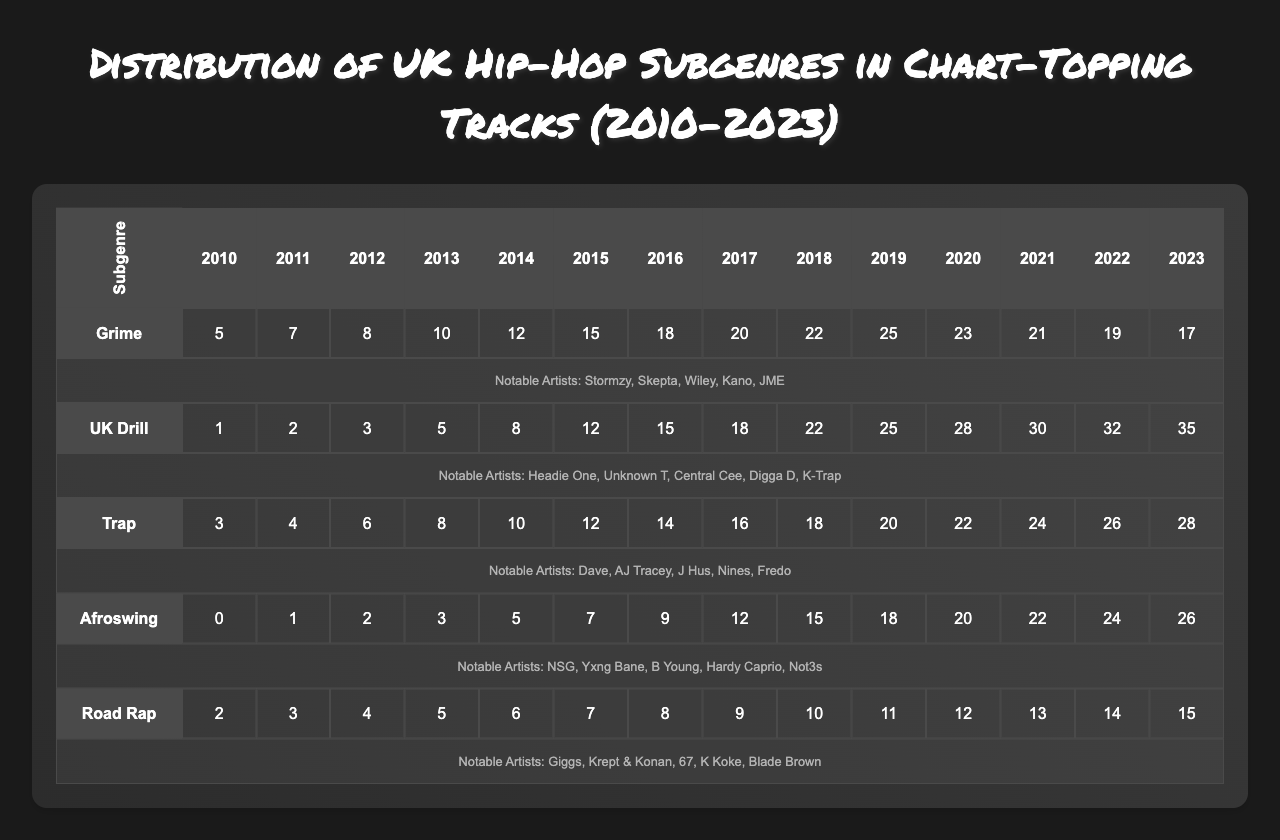What year had the highest number of chart-topping tracks for Grime? Looking at the data for Grime, the highest value is 25, which occurs in the year 2019.
Answer: 2019 Which subgenre consistently increased in chart-topping tracks from 2010 to 2023? Reviewing the data, UK Drill consistently increases each year from 1 in 2010 to 35 in 2023.
Answer: UK Drill In which year did Trap have the lowest number of chart-topping tracks? The lowest for Trap is 3, which occurs in 2010.
Answer: 2010 How many chart-topping tracks did Afroswing have in total from 2010 to 2023? Summing the Afroswing data gives: 0 + 1 + 2 + 3 + 5 + 7 + 9 + 12 + 15 + 18 + 20 + 22 + 24 + 26 = 142.
Answer: 142 Which subgenre had the most significant increase in tracks from 2014 to 2015? The data shows Road Rap had 6 tracks in 2014 and 7 in 2015, an increase of 1, while UK Drill had 8 in 2014 and 12 in 2015, an increase of 4. Hence, UK Drill had the most significant increase.
Answer: UK Drill In 2022, how many chart-topping tracks did each subgenre have? Checking the 2022 data: Grime had 19, UK Drill had 32, Trap had 26, Afroswing had 24, and Road Rap had 14.
Answer: Grime: 19, UK Drill: 32, Trap: 26, Afroswing: 24, Road Rap: 14 What is the average number of chart-topping tracks for Road Rap from 2010 to 2023? To find the average, sum the Road Rap data (2 + 3 + 4 + 5 + 6 + 7 + 8 + 9 + 10 + 11 + 12 + 13 + 14 + 15 = 116) and divide by the number of years (14): 116/14 = 8.29, so rounded gives 8.3.
Answer: 8.3 Has no notable artist announced for Afroswing? Yes, the notable artists for Afroswing include NSG, Yxng Bane, B Young, Hardy Caprio, and Not3s, confirming there are notable artists associated with this subgenre.
Answer: No Which subgenre had the highest number of chart-topping tracks in 2021? In 2021, UK Drill led with 30, followed by Trap with 24, making it the highest for that year.
Answer: UK Drill In what year did the number of chart-topping tracks for Trap exceed that of Grime for the first time? Analyzing from 2010 to 2023, Trap first exceeded Grime in 2016 where Trap had 12 and Grime had 18.
Answer: 2016 